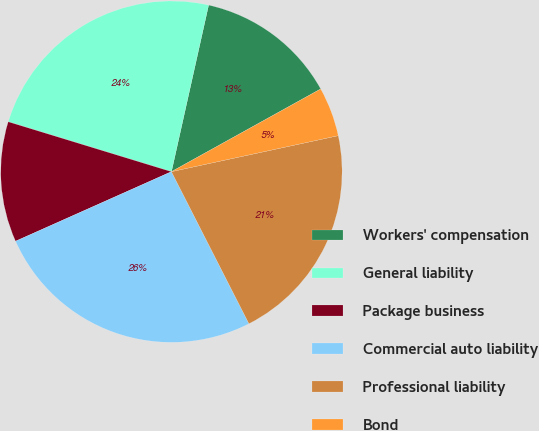Convert chart to OTSL. <chart><loc_0><loc_0><loc_500><loc_500><pie_chart><fcel>Workers' compensation<fcel>General liability<fcel>Package business<fcel>Commercial auto liability<fcel>Professional liability<fcel>Bond<nl><fcel>13.45%<fcel>23.77%<fcel>11.4%<fcel>25.82%<fcel>20.88%<fcel>4.67%<nl></chart> 